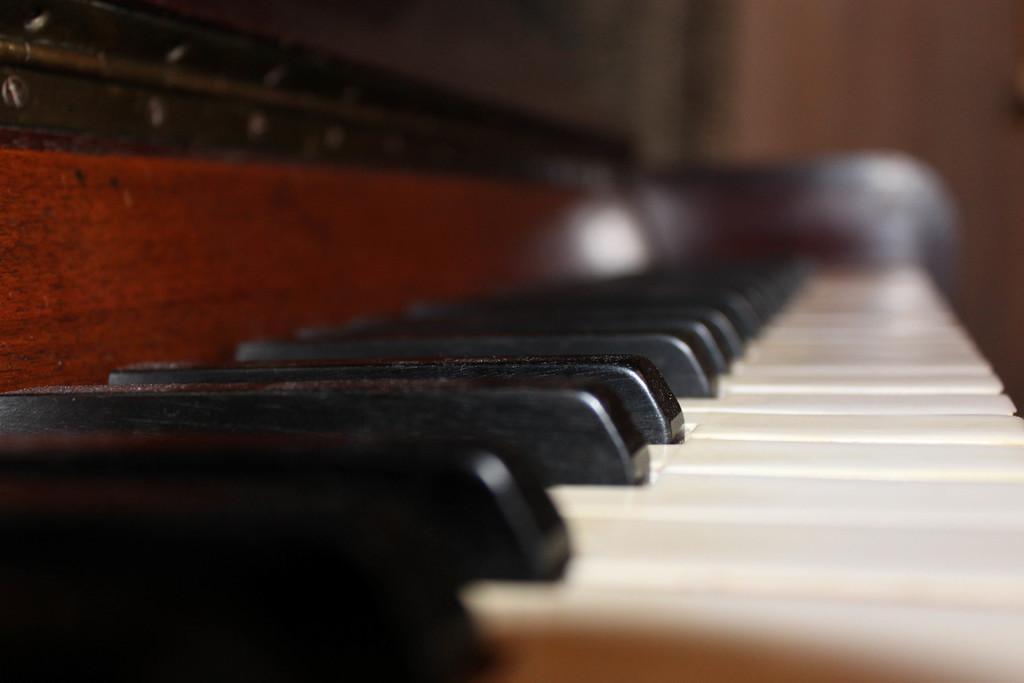Can you describe this image briefly? Piano with black and white buttons. 